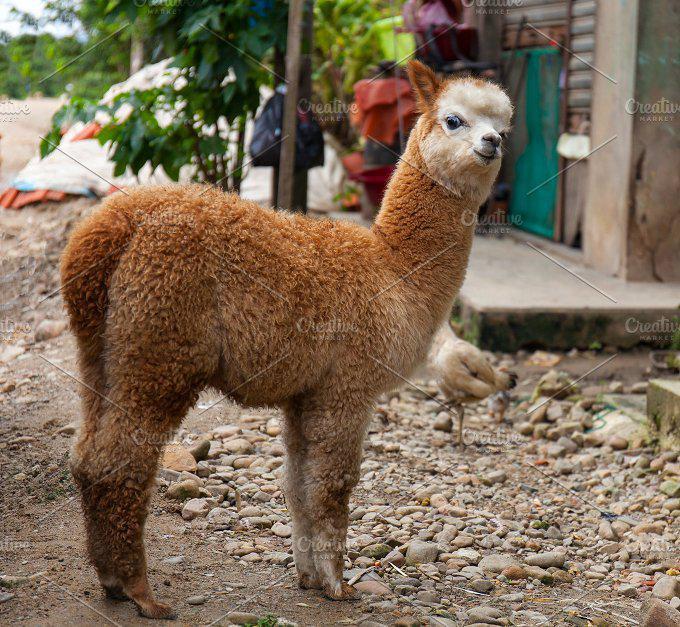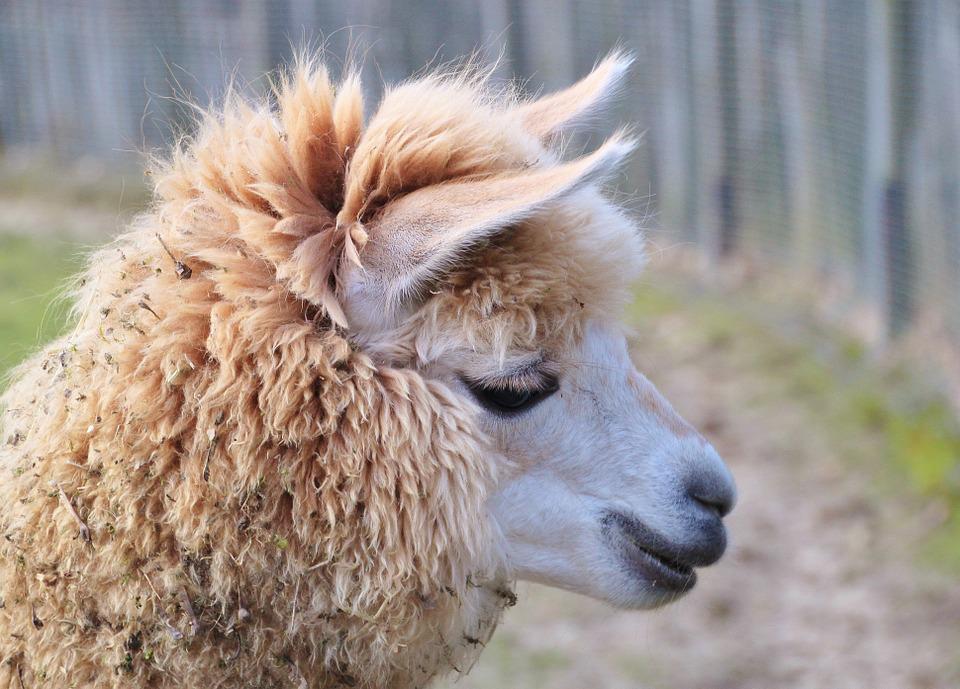The first image is the image on the left, the second image is the image on the right. Considering the images on both sides, is "The animal on the left has distinct facial coloring that is black with white streaks, while the animal on the right is predominantly white." valid? Answer yes or no. No. The first image is the image on the left, the second image is the image on the right. Analyze the images presented: Is the assertion "The right image shows a single llama with its face in profile, and the left image shows a single llama with a round fuzzy head." valid? Answer yes or no. Yes. 